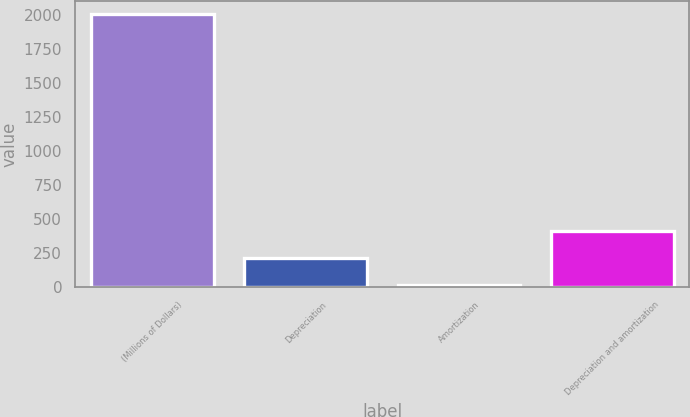Convert chart. <chart><loc_0><loc_0><loc_500><loc_500><bar_chart><fcel>(Millions of Dollars)<fcel>Depreciation<fcel>Amortization<fcel>Depreciation and amortization<nl><fcel>2005<fcel>211.93<fcel>12.7<fcel>411.16<nl></chart> 